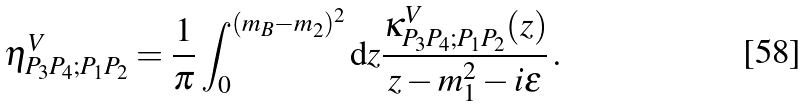<formula> <loc_0><loc_0><loc_500><loc_500>\eta _ { P _ { 3 } P _ { 4 } ; P _ { 1 } P _ { 2 } } ^ { V } = { \frac { 1 } { \pi } } \int _ { 0 } ^ { ( m _ { B } - m _ { 2 } ) ^ { 2 } } { \mathrm d } z { \frac { \kappa _ { P _ { 3 } P _ { 4 } ; P _ { 1 } P _ { 2 } } ^ { V } ( z ) } { z - m _ { 1 } ^ { 2 } - i \epsilon } } \, .</formula> 